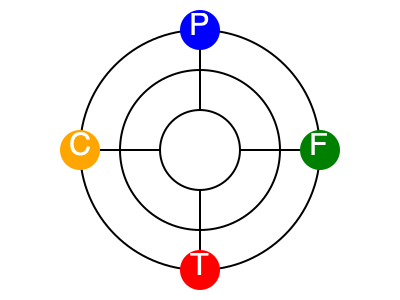Analyze the network diagram representing a rehabilitation participant's social support network. The diagram shows four key support groups: Personal (P), Family (F), Therapeutic (T), and Community (C). Each concentric circle represents the level of closeness to the participant, with the innermost circle being the closest. Based on this diagram, which support group appears to have the strongest potential impact on the participant's rehabilitation outcomes, and why? To analyze the impact of social support networks on rehabilitation outcomes using this network diagram, we need to consider several factors:

1. Proximity to the center: The closer a support group is to the center, the more immediate and potentially influential it is to the participant.

2. Number of connections: More connections indicate a broader support base, which can lead to better outcomes.

3. Type of support: Different support groups offer various types of assistance, each crucial for rehabilitation.

4. Position within the circles: The circle in which a support group is located indicates its level of closeness to the participant.

Analyzing each group:

1. Personal (P): Located in the innermost circle, suggesting the closest relationship to the participant. However, it has only one connection.

2. Family (F): Positioned in the middle circle, indicating a moderate level of closeness. It also has one connection.

3. Therapeutic (T): Located in the middle circle, similar to Family. It has one connection as well.

4. Community (C): Positioned in the outermost circle, suggesting the least close relationship. It also has one connection.

The Personal (P) support group appears to have the strongest potential impact on the participant's rehabilitation outcomes because:

1. It is located in the innermost circle, indicating the closest relationship to the participant.
2. Close personal relationships often provide emotional support, which is crucial for motivation and adherence to rehabilitation programs.
3. The proximity to the center suggests frequent interaction and immediate availability of support.

While all support groups are important for a holistic rehabilitation approach, the personal support network's closeness and immediacy give it the strongest potential to influence outcomes positively.
Answer: Personal (P) support group, due to its closest proximity to the participant in the network diagram. 